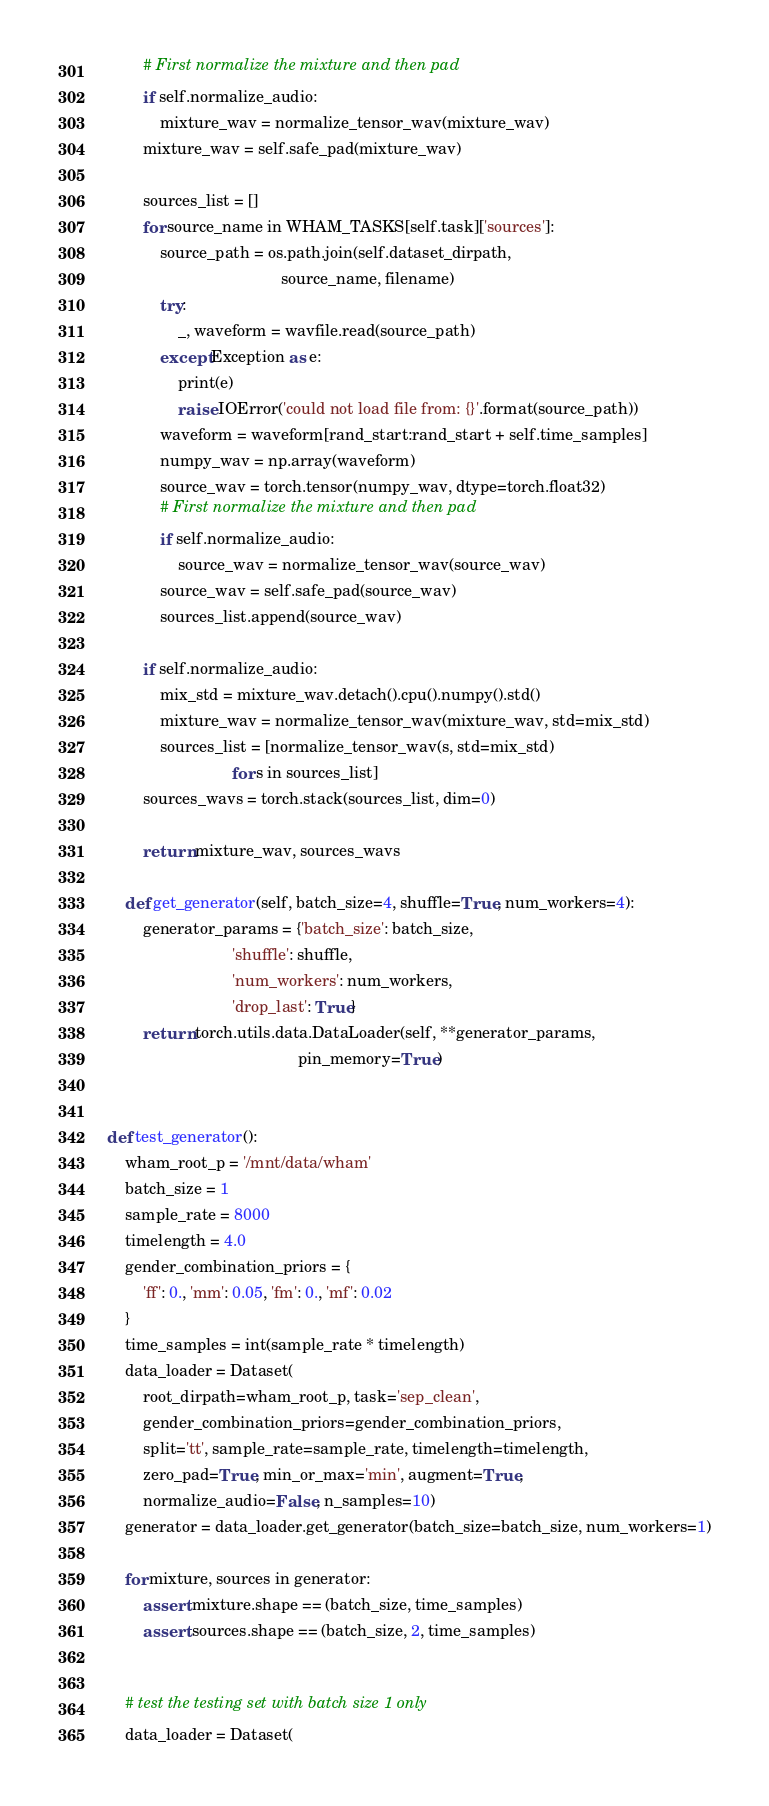<code> <loc_0><loc_0><loc_500><loc_500><_Python_>        # First normalize the mixture and then pad
        if self.normalize_audio:
            mixture_wav = normalize_tensor_wav(mixture_wav)
        mixture_wav = self.safe_pad(mixture_wav)

        sources_list = []
        for source_name in WHAM_TASKS[self.task]['sources']:
            source_path = os.path.join(self.dataset_dirpath,
                                       source_name, filename)
            try:
                _, waveform = wavfile.read(source_path)
            except Exception as e:
                print(e)
                raise IOError('could not load file from: {}'.format(source_path))
            waveform = waveform[rand_start:rand_start + self.time_samples]
            numpy_wav = np.array(waveform)
            source_wav = torch.tensor(numpy_wav, dtype=torch.float32)
            # First normalize the mixture and then pad
            if self.normalize_audio:
                source_wav = normalize_tensor_wav(source_wav)
            source_wav = self.safe_pad(source_wav)
            sources_list.append(source_wav)

        if self.normalize_audio:
            mix_std = mixture_wav.detach().cpu().numpy().std()
            mixture_wav = normalize_tensor_wav(mixture_wav, std=mix_std)
            sources_list = [normalize_tensor_wav(s, std=mix_std)
                            for s in sources_list]
        sources_wavs = torch.stack(sources_list, dim=0)

        return mixture_wav, sources_wavs

    def get_generator(self, batch_size=4, shuffle=True, num_workers=4):
        generator_params = {'batch_size': batch_size,
                            'shuffle': shuffle,
                            'num_workers': num_workers,
                            'drop_last': True}
        return torch.utils.data.DataLoader(self, **generator_params,
                                           pin_memory=True)


def test_generator():
    wham_root_p = '/mnt/data/wham'
    batch_size = 1
    sample_rate = 8000
    timelength = 4.0
    gender_combination_priors = {
        'ff': 0., 'mm': 0.05, 'fm': 0., 'mf': 0.02
    }
    time_samples = int(sample_rate * timelength)
    data_loader = Dataset(
        root_dirpath=wham_root_p, task='sep_clean',
        gender_combination_priors=gender_combination_priors,
        split='tt', sample_rate=sample_rate, timelength=timelength,
        zero_pad=True, min_or_max='min', augment=True,
        normalize_audio=False, n_samples=10)
    generator = data_loader.get_generator(batch_size=batch_size, num_workers=1)

    for mixture, sources in generator:
        assert mixture.shape == (batch_size, time_samples)
        assert sources.shape == (batch_size, 2, time_samples)


    # test the testing set with batch size 1 only
    data_loader = Dataset(</code> 